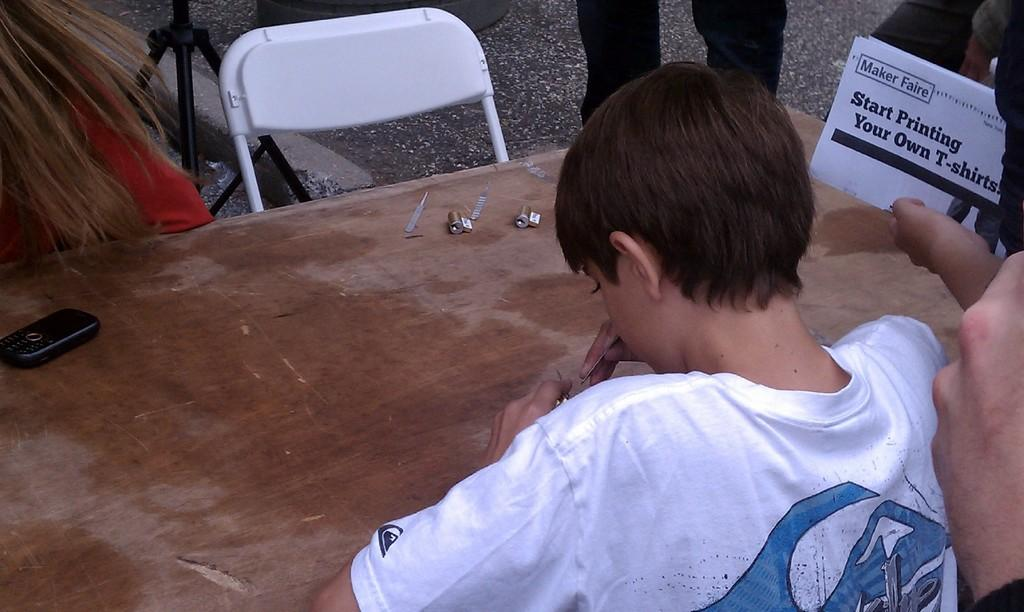Who is in the image? There is a boy in the image. What is the boy doing in the image? The boy is sitting on a chair in the image. What object is present on a table in the image? There is a phone on a table in the image. What type of birds can be seen flying around the boy in the image? There are no birds present in the image. What word is the boy saying in the image? The image does not provide any information about the boy's speech or words. 